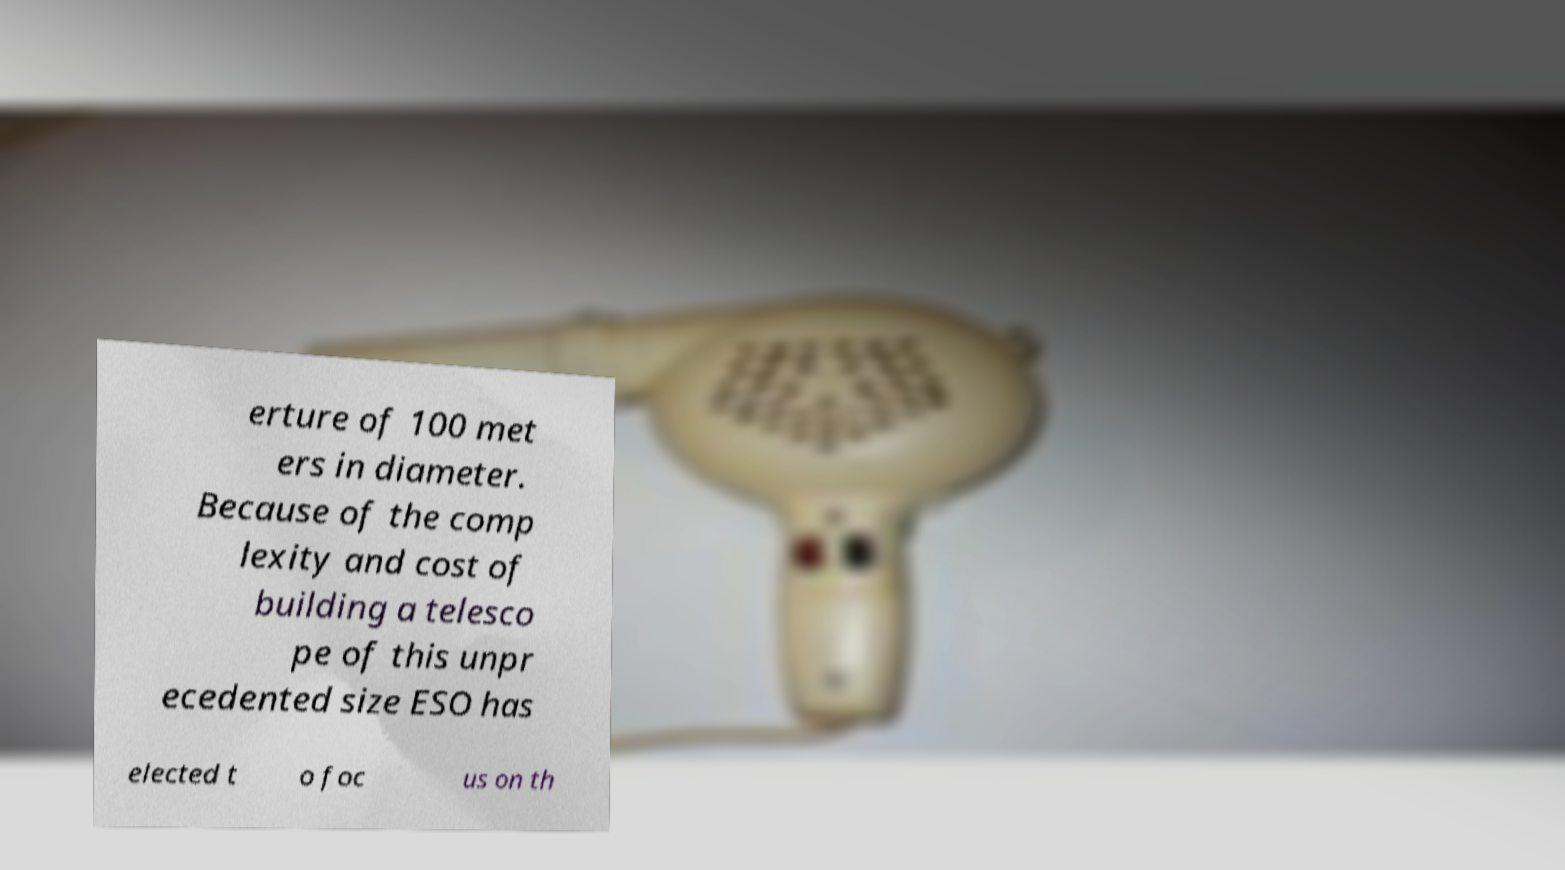Could you assist in decoding the text presented in this image and type it out clearly? erture of 100 met ers in diameter. Because of the comp lexity and cost of building a telesco pe of this unpr ecedented size ESO has elected t o foc us on th 